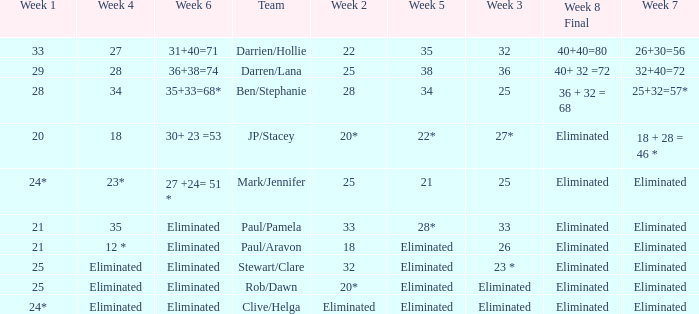Name the week 6 when week 3 is 25 and week 7 is eliminated 27 +24= 51 *. 